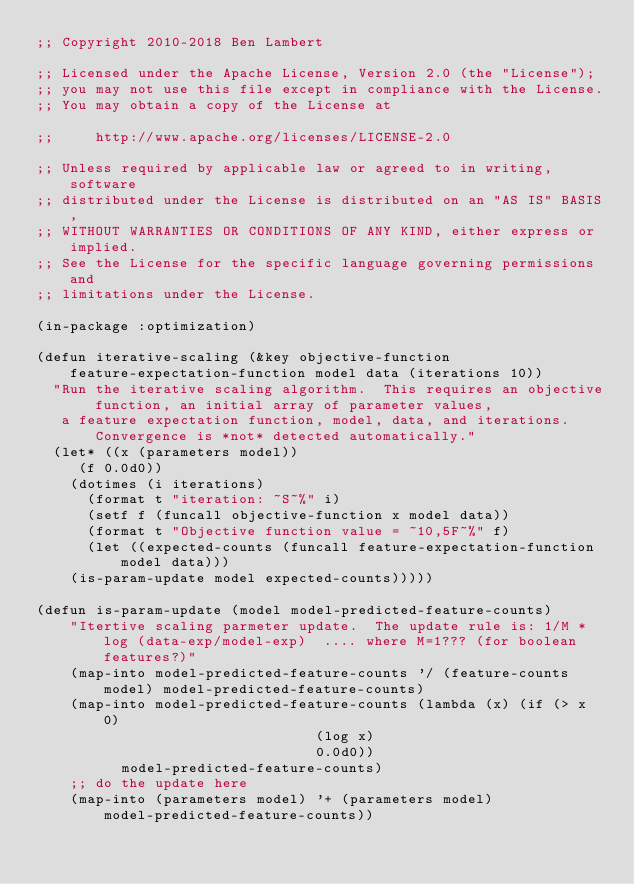Convert code to text. <code><loc_0><loc_0><loc_500><loc_500><_Lisp_>;; Copyright 2010-2018 Ben Lambert

;; Licensed under the Apache License, Version 2.0 (the "License");
;; you may not use this file except in compliance with the License.
;; You may obtain a copy of the License at

;;     http://www.apache.org/licenses/LICENSE-2.0

;; Unless required by applicable law or agreed to in writing, software
;; distributed under the License is distributed on an "AS IS" BASIS,
;; WITHOUT WARRANTIES OR CONDITIONS OF ANY KIND, either express or implied.
;; See the License for the specific language governing permissions and
;; limitations under the License.

(in-package :optimization)

(defun iterative-scaling (&key objective-function feature-expectation-function model data (iterations 10))
  "Run the iterative scaling algorithm.  This requires an objective function, an initial array of parameter values,
   a feature expectation function, model, data, and iterations.  Convergence is *not* detected automatically."
  (let* ((x (parameters model))
	 (f 0.0d0))
    (dotimes (i iterations)
      (format t "iteration: ~S~%" i)
      (setf f (funcall objective-function x model data))
      (format t "Objective function value = ~10,5F~%" f)
      (let ((expected-counts (funcall feature-expectation-function model data)))
	(is-param-update model expected-counts)))))

(defun is-param-update (model model-predicted-feature-counts)
    "Itertive scaling parmeter update.  The update rule is: 1/M * log (data-exp/model-exp)  .... where M=1??? (for boolean features?)"
    (map-into model-predicted-feature-counts '/ (feature-counts model) model-predicted-feature-counts)
    (map-into model-predicted-feature-counts (lambda (x) (if (> x 0)
							     (log x)
							     0.0d0))
	      model-predicted-feature-counts)
    ;; do the update here
    (map-into (parameters model) '+ (parameters model) model-predicted-feature-counts))
</code> 